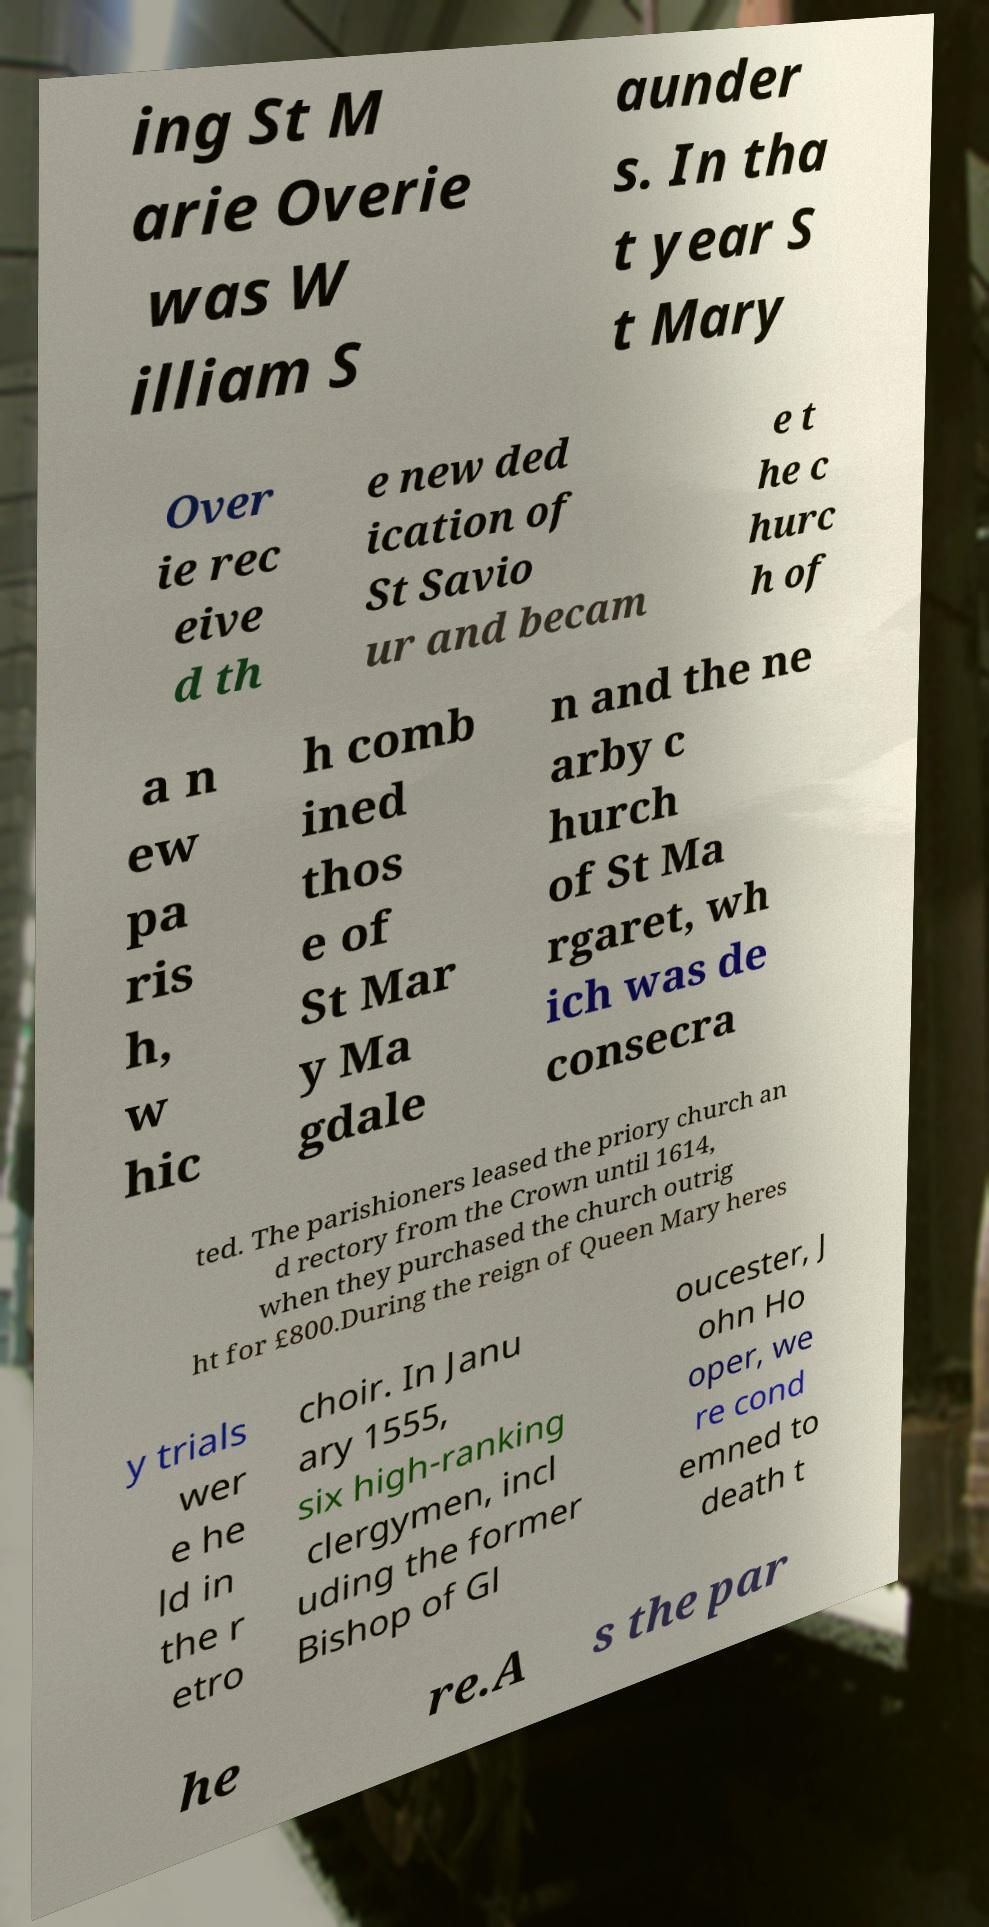Can you read and provide the text displayed in the image?This photo seems to have some interesting text. Can you extract and type it out for me? ing St M arie Overie was W illiam S aunder s. In tha t year S t Mary Over ie rec eive d th e new ded ication of St Savio ur and becam e t he c hurc h of a n ew pa ris h, w hic h comb ined thos e of St Mar y Ma gdale n and the ne arby c hurch of St Ma rgaret, wh ich was de consecra ted. The parishioners leased the priory church an d rectory from the Crown until 1614, when they purchased the church outrig ht for £800.During the reign of Queen Mary heres y trials wer e he ld in the r etro choir. In Janu ary 1555, six high-ranking clergymen, incl uding the former Bishop of Gl oucester, J ohn Ho oper, we re cond emned to death t he re.A s the par 